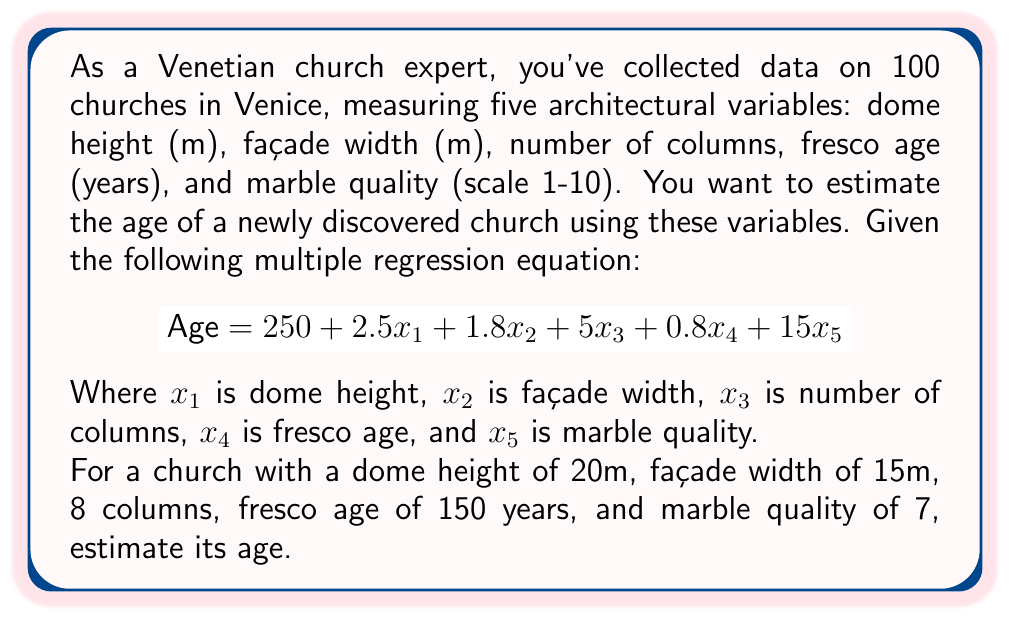Could you help me with this problem? To estimate the age of the church, we need to substitute the given values into the multiple regression equation:

1. Substitute the values:
   $x_1 = 20$ (dome height)
   $x_2 = 15$ (façade width)
   $x_3 = 8$ (number of columns)
   $x_4 = 150$ (fresco age)
   $x_5 = 7$ (marble quality)

2. Insert these values into the equation:
   $$\text{Age} = 250 + 2.5(20) + 1.8(15) + 5(8) + 0.8(150) + 15(7)$$

3. Calculate each term:
   $$\text{Age} = 250 + 50 + 27 + 40 + 120 + 105$$

4. Sum up all terms:
   $$\text{Age} = 592$$

Therefore, the estimated age of the church based on the given architectural variables is 592 years.
Answer: 592 years 